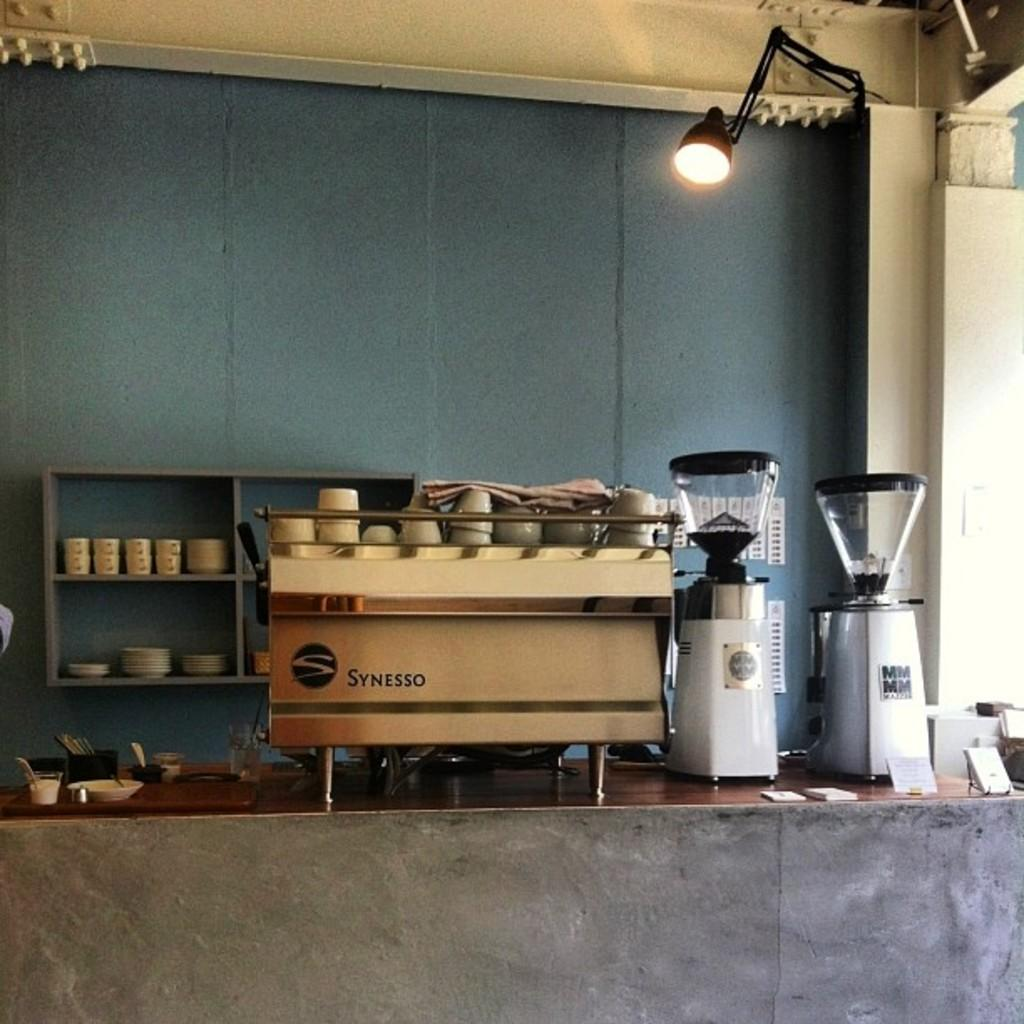<image>
Share a concise interpretation of the image provided. A Synesso machine sits on a counter in a restaurant. 